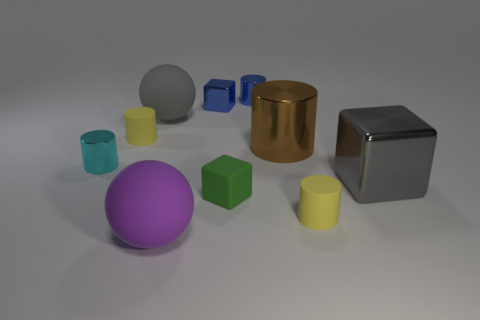Subtract all small blocks. How many blocks are left? 1 Subtract all blue cylinders. How many cylinders are left? 4 Subtract all spheres. How many objects are left? 8 Subtract 3 blocks. How many blocks are left? 0 Subtract all red spheres. Subtract all green cylinders. How many spheres are left? 2 Subtract all cyan cubes. How many green spheres are left? 0 Subtract all large gray cubes. Subtract all shiny blocks. How many objects are left? 7 Add 3 tiny cyan cylinders. How many tiny cyan cylinders are left? 4 Add 8 large metal cubes. How many large metal cubes exist? 9 Subtract 1 brown cylinders. How many objects are left? 9 